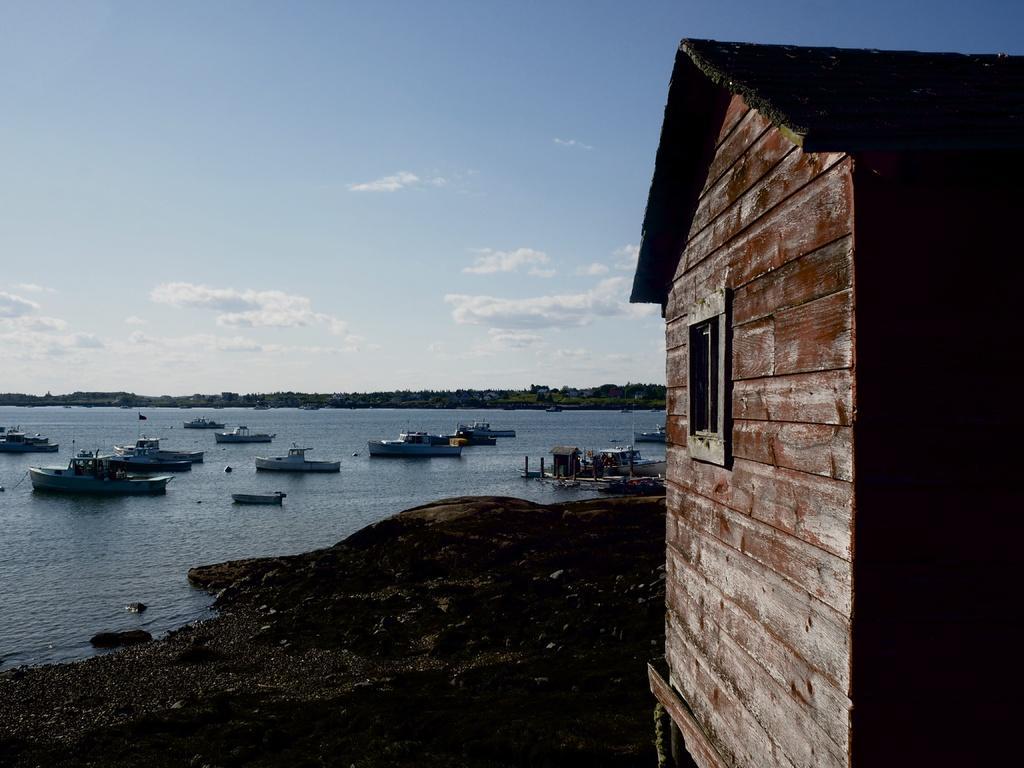In one or two sentences, can you explain what this image depicts? In this image I can see the house, background I can see few boats on the water and the sky is in white and blue color. 